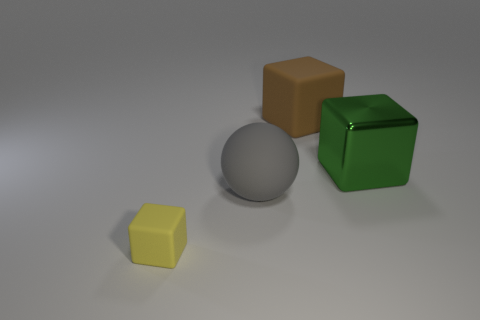Are there any other things that have the same material as the large green object?
Ensure brevity in your answer.  No. Are there any objects that are in front of the rubber block that is behind the large gray matte sphere?
Keep it short and to the point. Yes. Is there another large green cube made of the same material as the big green cube?
Your response must be concise. No. The small yellow block on the left side of the block behind the green thing is made of what material?
Your response must be concise. Rubber. There is a cube that is to the left of the big green block and on the right side of the gray thing; what is its material?
Your response must be concise. Rubber. Are there an equal number of small yellow blocks behind the rubber ball and big metal spheres?
Provide a short and direct response. Yes. What number of other yellow things are the same shape as the small yellow rubber thing?
Ensure brevity in your answer.  0. How big is the cube in front of the large rubber object that is in front of the matte block on the right side of the yellow rubber thing?
Your answer should be very brief. Small. Is the material of the thing on the right side of the large rubber block the same as the large brown cube?
Offer a very short reply. No. Are there an equal number of small matte objects to the right of the big gray rubber object and brown matte cubes behind the big brown cube?
Your response must be concise. Yes. 